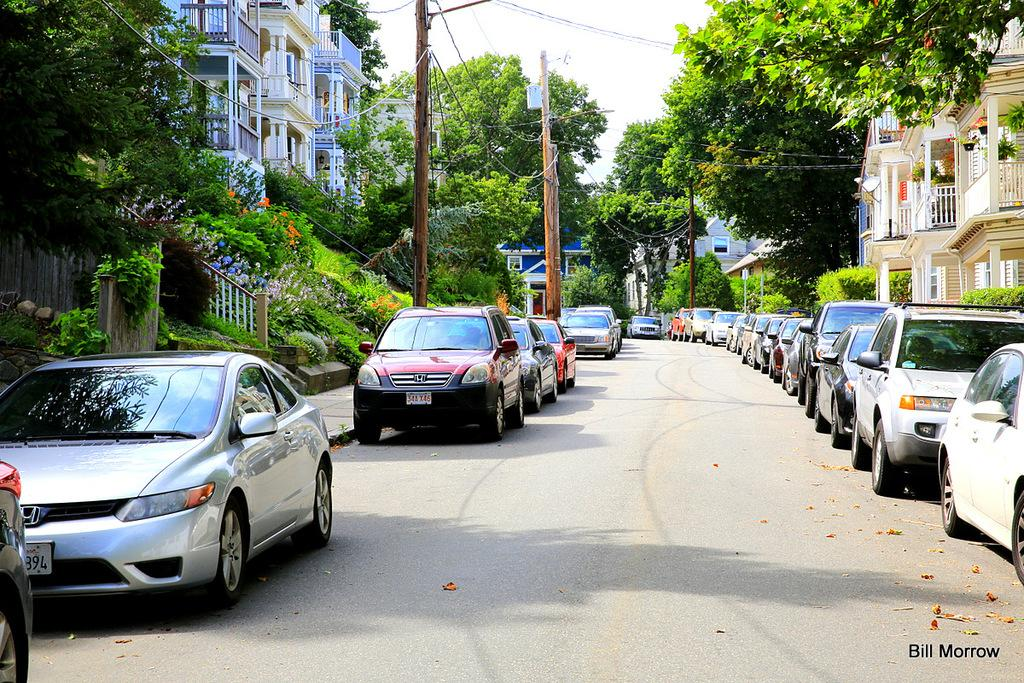What can be seen in the foreground of the image? There are vehicles in the front of the image. What is visible in the background of the image? There are trees, poles, and buildings in the background of the image. What type of mist can be seen surrounding the vehicles in the image? There is no mist present in the image; the vehicles are visible without any obscuring elements. What riddle is being solved by the trees in the background of the image? There is no riddle being solved by the trees in the image; they are simply part of the background scenery. 